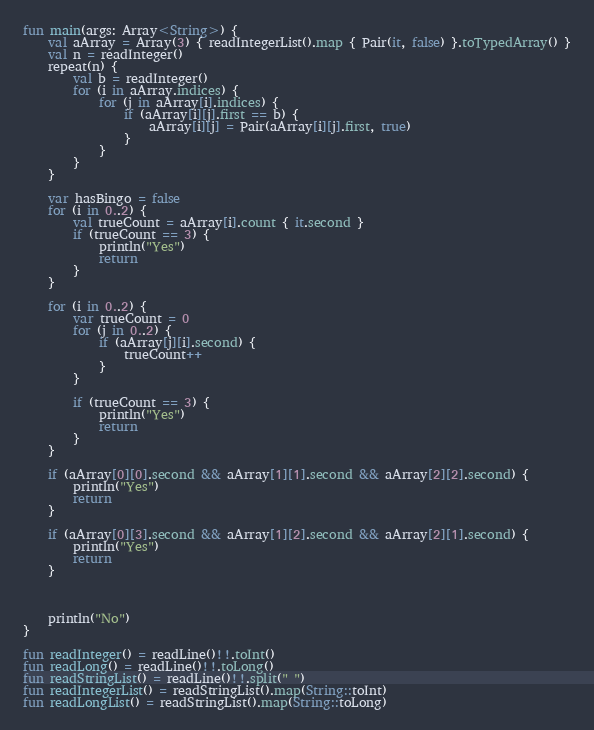Convert code to text. <code><loc_0><loc_0><loc_500><loc_500><_Kotlin_>fun main(args: Array<String>) {
    val aArray = Array(3) { readIntegerList().map { Pair(it, false) }.toTypedArray() }
    val n = readInteger()
    repeat(n) {
        val b = readInteger()
        for (i in aArray.indices) {
            for (j in aArray[i].indices) {
                if (aArray[i][j].first == b) {
                    aArray[i][j] = Pair(aArray[i][j].first, true)
                }
            }
        }
    }

    var hasBingo = false
    for (i in 0..2) {
        val trueCount = aArray[i].count { it.second }
        if (trueCount == 3) {
            println("Yes")
            return
        }
    }

    for (i in 0..2) {
        var trueCount = 0
        for (j in 0..2) {
            if (aArray[j][i].second) {
                trueCount++
            }
        }

        if (trueCount == 3) {
            println("Yes")
            return
        }
    }

    if (aArray[0][0].second && aArray[1][1].second && aArray[2][2].second) {
        println("Yes")
        return
    }

    if (aArray[0][3].second && aArray[1][2].second && aArray[2][1].second) {
        println("Yes")
        return
    }



    println("No")
}

fun readInteger() = readLine()!!.toInt()
fun readLong() = readLine()!!.toLong()
fun readStringList() = readLine()!!.split(" ")
fun readIntegerList() = readStringList().map(String::toInt)
fun readLongList() = readStringList().map(String::toLong)
</code> 